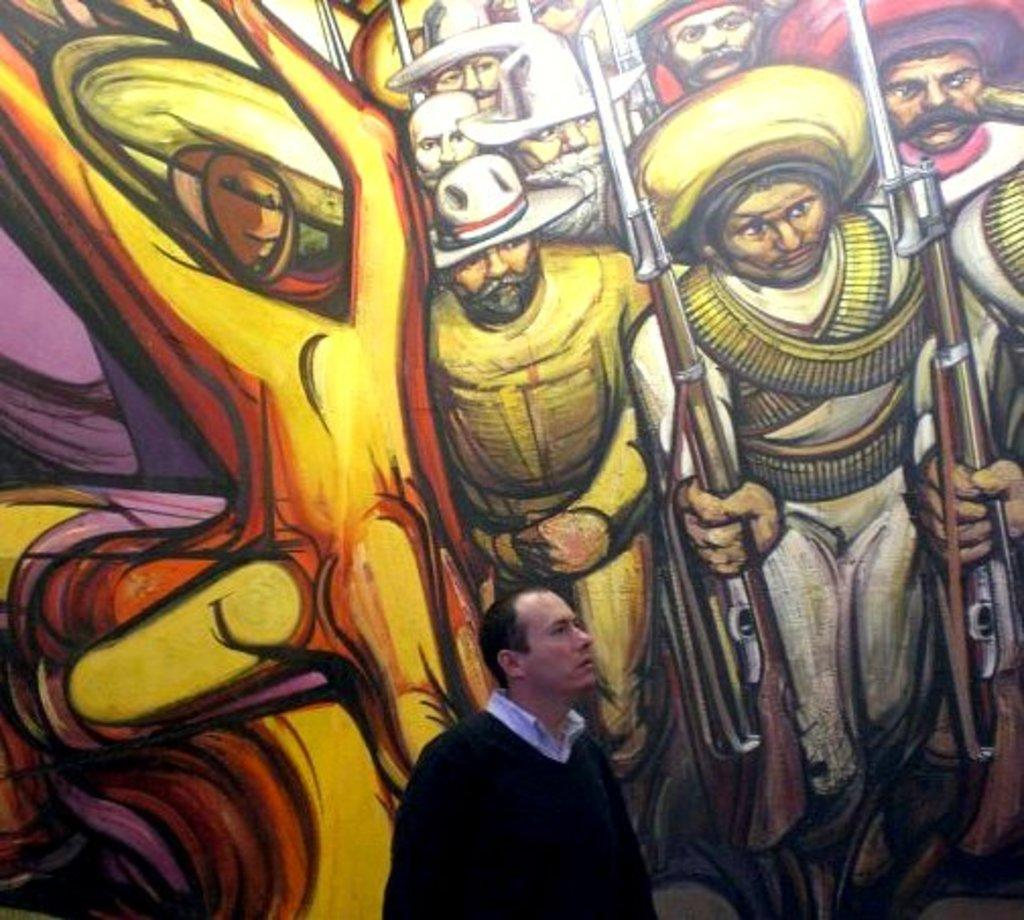What is the main subject of the image? There is a man standing in the image. Where is the man located in the image? The man is standing on a path. What can be seen behind the man in the image? There is a wall with paintings behind the man. What type of operation is the man performing on the basin in the image? There is no basin present in the image, and the man is not performing any operation. 